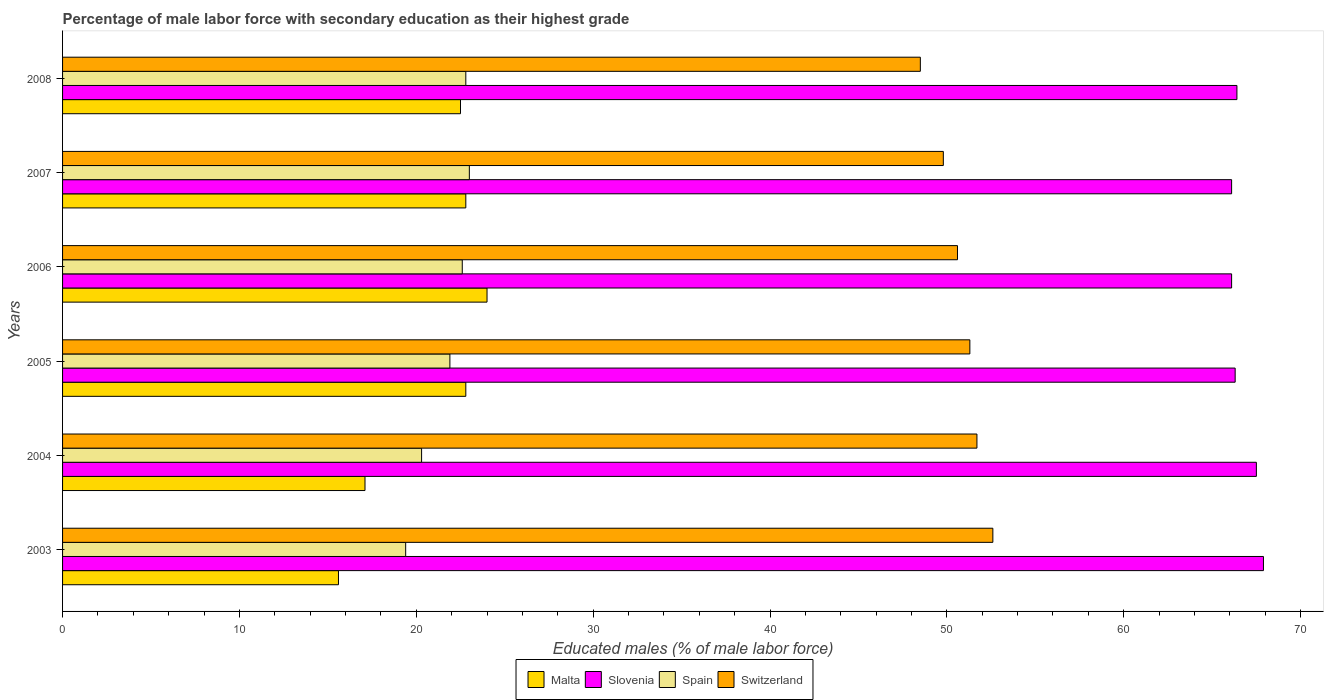How many different coloured bars are there?
Keep it short and to the point. 4. How many groups of bars are there?
Ensure brevity in your answer.  6. Are the number of bars per tick equal to the number of legend labels?
Offer a terse response. Yes. Are the number of bars on each tick of the Y-axis equal?
Your answer should be very brief. Yes. How many bars are there on the 6th tick from the bottom?
Provide a succinct answer. 4. What is the label of the 5th group of bars from the top?
Make the answer very short. 2004. In how many cases, is the number of bars for a given year not equal to the number of legend labels?
Provide a short and direct response. 0. What is the percentage of male labor force with secondary education in Slovenia in 2003?
Offer a terse response. 67.9. Across all years, what is the maximum percentage of male labor force with secondary education in Slovenia?
Provide a short and direct response. 67.9. Across all years, what is the minimum percentage of male labor force with secondary education in Spain?
Provide a succinct answer. 19.4. In which year was the percentage of male labor force with secondary education in Slovenia maximum?
Your answer should be very brief. 2003. In which year was the percentage of male labor force with secondary education in Slovenia minimum?
Offer a very short reply. 2006. What is the total percentage of male labor force with secondary education in Slovenia in the graph?
Give a very brief answer. 400.3. What is the difference between the percentage of male labor force with secondary education in Switzerland in 2004 and the percentage of male labor force with secondary education in Slovenia in 2008?
Provide a succinct answer. -14.7. What is the average percentage of male labor force with secondary education in Switzerland per year?
Offer a terse response. 50.75. In the year 2007, what is the difference between the percentage of male labor force with secondary education in Switzerland and percentage of male labor force with secondary education in Spain?
Provide a short and direct response. 26.8. What is the ratio of the percentage of male labor force with secondary education in Malta in 2003 to that in 2007?
Make the answer very short. 0.68. Is the percentage of male labor force with secondary education in Malta in 2006 less than that in 2008?
Your answer should be compact. No. What is the difference between the highest and the second highest percentage of male labor force with secondary education in Spain?
Give a very brief answer. 0.2. What is the difference between the highest and the lowest percentage of male labor force with secondary education in Malta?
Offer a terse response. 8.4. In how many years, is the percentage of male labor force with secondary education in Spain greater than the average percentage of male labor force with secondary education in Spain taken over all years?
Make the answer very short. 4. What does the 4th bar from the bottom in 2005 represents?
Offer a very short reply. Switzerland. Is it the case that in every year, the sum of the percentage of male labor force with secondary education in Switzerland and percentage of male labor force with secondary education in Spain is greater than the percentage of male labor force with secondary education in Malta?
Make the answer very short. Yes. Are the values on the major ticks of X-axis written in scientific E-notation?
Make the answer very short. No. Does the graph contain any zero values?
Make the answer very short. No. Does the graph contain grids?
Give a very brief answer. No. Where does the legend appear in the graph?
Provide a succinct answer. Bottom center. How many legend labels are there?
Ensure brevity in your answer.  4. What is the title of the graph?
Keep it short and to the point. Percentage of male labor force with secondary education as their highest grade. What is the label or title of the X-axis?
Keep it short and to the point. Educated males (% of male labor force). What is the Educated males (% of male labor force) in Malta in 2003?
Your answer should be compact. 15.6. What is the Educated males (% of male labor force) of Slovenia in 2003?
Your answer should be very brief. 67.9. What is the Educated males (% of male labor force) of Spain in 2003?
Provide a succinct answer. 19.4. What is the Educated males (% of male labor force) in Switzerland in 2003?
Ensure brevity in your answer.  52.6. What is the Educated males (% of male labor force) of Malta in 2004?
Ensure brevity in your answer.  17.1. What is the Educated males (% of male labor force) of Slovenia in 2004?
Your answer should be very brief. 67.5. What is the Educated males (% of male labor force) in Spain in 2004?
Offer a terse response. 20.3. What is the Educated males (% of male labor force) in Switzerland in 2004?
Your answer should be compact. 51.7. What is the Educated males (% of male labor force) of Malta in 2005?
Provide a succinct answer. 22.8. What is the Educated males (% of male labor force) of Slovenia in 2005?
Provide a short and direct response. 66.3. What is the Educated males (% of male labor force) of Spain in 2005?
Your answer should be very brief. 21.9. What is the Educated males (% of male labor force) of Switzerland in 2005?
Your answer should be compact. 51.3. What is the Educated males (% of male labor force) in Malta in 2006?
Your answer should be very brief. 24. What is the Educated males (% of male labor force) in Slovenia in 2006?
Make the answer very short. 66.1. What is the Educated males (% of male labor force) in Spain in 2006?
Ensure brevity in your answer.  22.6. What is the Educated males (% of male labor force) in Switzerland in 2006?
Provide a succinct answer. 50.6. What is the Educated males (% of male labor force) of Malta in 2007?
Make the answer very short. 22.8. What is the Educated males (% of male labor force) of Slovenia in 2007?
Offer a terse response. 66.1. What is the Educated males (% of male labor force) in Switzerland in 2007?
Provide a short and direct response. 49.8. What is the Educated males (% of male labor force) in Malta in 2008?
Provide a succinct answer. 22.5. What is the Educated males (% of male labor force) of Slovenia in 2008?
Your response must be concise. 66.4. What is the Educated males (% of male labor force) in Spain in 2008?
Your answer should be compact. 22.8. What is the Educated males (% of male labor force) of Switzerland in 2008?
Make the answer very short. 48.5. Across all years, what is the maximum Educated males (% of male labor force) of Malta?
Provide a succinct answer. 24. Across all years, what is the maximum Educated males (% of male labor force) of Slovenia?
Provide a short and direct response. 67.9. Across all years, what is the maximum Educated males (% of male labor force) in Spain?
Your response must be concise. 23. Across all years, what is the maximum Educated males (% of male labor force) of Switzerland?
Provide a succinct answer. 52.6. Across all years, what is the minimum Educated males (% of male labor force) in Malta?
Offer a very short reply. 15.6. Across all years, what is the minimum Educated males (% of male labor force) in Slovenia?
Provide a succinct answer. 66.1. Across all years, what is the minimum Educated males (% of male labor force) in Spain?
Offer a terse response. 19.4. Across all years, what is the minimum Educated males (% of male labor force) of Switzerland?
Provide a succinct answer. 48.5. What is the total Educated males (% of male labor force) of Malta in the graph?
Your response must be concise. 124.8. What is the total Educated males (% of male labor force) of Slovenia in the graph?
Provide a succinct answer. 400.3. What is the total Educated males (% of male labor force) in Spain in the graph?
Your answer should be very brief. 130. What is the total Educated males (% of male labor force) in Switzerland in the graph?
Make the answer very short. 304.5. What is the difference between the Educated males (% of male labor force) of Malta in 2003 and that in 2004?
Give a very brief answer. -1.5. What is the difference between the Educated males (% of male labor force) in Spain in 2003 and that in 2004?
Keep it short and to the point. -0.9. What is the difference between the Educated males (% of male labor force) of Malta in 2003 and that in 2005?
Your answer should be very brief. -7.2. What is the difference between the Educated males (% of male labor force) of Slovenia in 2003 and that in 2005?
Ensure brevity in your answer.  1.6. What is the difference between the Educated males (% of male labor force) of Switzerland in 2003 and that in 2005?
Offer a terse response. 1.3. What is the difference between the Educated males (% of male labor force) of Malta in 2003 and that in 2006?
Give a very brief answer. -8.4. What is the difference between the Educated males (% of male labor force) in Malta in 2003 and that in 2007?
Offer a very short reply. -7.2. What is the difference between the Educated males (% of male labor force) in Slovenia in 2003 and that in 2007?
Offer a terse response. 1.8. What is the difference between the Educated males (% of male labor force) of Spain in 2003 and that in 2007?
Keep it short and to the point. -3.6. What is the difference between the Educated males (% of male labor force) in Switzerland in 2003 and that in 2007?
Provide a succinct answer. 2.8. What is the difference between the Educated males (% of male labor force) of Malta in 2003 and that in 2008?
Keep it short and to the point. -6.9. What is the difference between the Educated males (% of male labor force) of Slovenia in 2003 and that in 2008?
Your response must be concise. 1.5. What is the difference between the Educated males (% of male labor force) in Malta in 2004 and that in 2005?
Your response must be concise. -5.7. What is the difference between the Educated males (% of male labor force) in Spain in 2004 and that in 2005?
Make the answer very short. -1.6. What is the difference between the Educated males (% of male labor force) of Malta in 2004 and that in 2006?
Your response must be concise. -6.9. What is the difference between the Educated males (% of male labor force) of Slovenia in 2004 and that in 2006?
Provide a succinct answer. 1.4. What is the difference between the Educated males (% of male labor force) in Spain in 2004 and that in 2006?
Ensure brevity in your answer.  -2.3. What is the difference between the Educated males (% of male labor force) of Spain in 2004 and that in 2007?
Offer a terse response. -2.7. What is the difference between the Educated males (% of male labor force) of Switzerland in 2004 and that in 2007?
Offer a terse response. 1.9. What is the difference between the Educated males (% of male labor force) in Slovenia in 2004 and that in 2008?
Keep it short and to the point. 1.1. What is the difference between the Educated males (% of male labor force) of Switzerland in 2004 and that in 2008?
Make the answer very short. 3.2. What is the difference between the Educated males (% of male labor force) of Malta in 2005 and that in 2006?
Keep it short and to the point. -1.2. What is the difference between the Educated males (% of male labor force) of Slovenia in 2005 and that in 2006?
Your answer should be compact. 0.2. What is the difference between the Educated males (% of male labor force) of Switzerland in 2005 and that in 2006?
Offer a very short reply. 0.7. What is the difference between the Educated males (% of male labor force) of Slovenia in 2005 and that in 2007?
Provide a succinct answer. 0.2. What is the difference between the Educated males (% of male labor force) in Spain in 2005 and that in 2007?
Provide a short and direct response. -1.1. What is the difference between the Educated males (% of male labor force) of Slovenia in 2005 and that in 2008?
Give a very brief answer. -0.1. What is the difference between the Educated males (% of male labor force) in Switzerland in 2005 and that in 2008?
Make the answer very short. 2.8. What is the difference between the Educated males (% of male labor force) of Slovenia in 2006 and that in 2007?
Offer a terse response. 0. What is the difference between the Educated males (% of male labor force) in Spain in 2006 and that in 2007?
Give a very brief answer. -0.4. What is the difference between the Educated males (% of male labor force) of Switzerland in 2006 and that in 2007?
Offer a very short reply. 0.8. What is the difference between the Educated males (% of male labor force) in Malta in 2006 and that in 2008?
Provide a succinct answer. 1.5. What is the difference between the Educated males (% of male labor force) of Spain in 2006 and that in 2008?
Give a very brief answer. -0.2. What is the difference between the Educated males (% of male labor force) in Malta in 2007 and that in 2008?
Offer a very short reply. 0.3. What is the difference between the Educated males (% of male labor force) in Spain in 2007 and that in 2008?
Your answer should be very brief. 0.2. What is the difference between the Educated males (% of male labor force) of Switzerland in 2007 and that in 2008?
Your answer should be very brief. 1.3. What is the difference between the Educated males (% of male labor force) in Malta in 2003 and the Educated males (% of male labor force) in Slovenia in 2004?
Make the answer very short. -51.9. What is the difference between the Educated males (% of male labor force) of Malta in 2003 and the Educated males (% of male labor force) of Spain in 2004?
Keep it short and to the point. -4.7. What is the difference between the Educated males (% of male labor force) of Malta in 2003 and the Educated males (% of male labor force) of Switzerland in 2004?
Your response must be concise. -36.1. What is the difference between the Educated males (% of male labor force) of Slovenia in 2003 and the Educated males (% of male labor force) of Spain in 2004?
Ensure brevity in your answer.  47.6. What is the difference between the Educated males (% of male labor force) in Spain in 2003 and the Educated males (% of male labor force) in Switzerland in 2004?
Provide a succinct answer. -32.3. What is the difference between the Educated males (% of male labor force) in Malta in 2003 and the Educated males (% of male labor force) in Slovenia in 2005?
Provide a succinct answer. -50.7. What is the difference between the Educated males (% of male labor force) in Malta in 2003 and the Educated males (% of male labor force) in Switzerland in 2005?
Give a very brief answer. -35.7. What is the difference between the Educated males (% of male labor force) of Slovenia in 2003 and the Educated males (% of male labor force) of Spain in 2005?
Your response must be concise. 46. What is the difference between the Educated males (% of male labor force) of Spain in 2003 and the Educated males (% of male labor force) of Switzerland in 2005?
Ensure brevity in your answer.  -31.9. What is the difference between the Educated males (% of male labor force) of Malta in 2003 and the Educated males (% of male labor force) of Slovenia in 2006?
Give a very brief answer. -50.5. What is the difference between the Educated males (% of male labor force) in Malta in 2003 and the Educated males (% of male labor force) in Switzerland in 2006?
Offer a terse response. -35. What is the difference between the Educated males (% of male labor force) in Slovenia in 2003 and the Educated males (% of male labor force) in Spain in 2006?
Offer a very short reply. 45.3. What is the difference between the Educated males (% of male labor force) of Spain in 2003 and the Educated males (% of male labor force) of Switzerland in 2006?
Keep it short and to the point. -31.2. What is the difference between the Educated males (% of male labor force) in Malta in 2003 and the Educated males (% of male labor force) in Slovenia in 2007?
Make the answer very short. -50.5. What is the difference between the Educated males (% of male labor force) in Malta in 2003 and the Educated males (% of male labor force) in Spain in 2007?
Ensure brevity in your answer.  -7.4. What is the difference between the Educated males (% of male labor force) of Malta in 2003 and the Educated males (% of male labor force) of Switzerland in 2007?
Make the answer very short. -34.2. What is the difference between the Educated males (% of male labor force) in Slovenia in 2003 and the Educated males (% of male labor force) in Spain in 2007?
Keep it short and to the point. 44.9. What is the difference between the Educated males (% of male labor force) of Slovenia in 2003 and the Educated males (% of male labor force) of Switzerland in 2007?
Make the answer very short. 18.1. What is the difference between the Educated males (% of male labor force) in Spain in 2003 and the Educated males (% of male labor force) in Switzerland in 2007?
Your answer should be compact. -30.4. What is the difference between the Educated males (% of male labor force) in Malta in 2003 and the Educated males (% of male labor force) in Slovenia in 2008?
Keep it short and to the point. -50.8. What is the difference between the Educated males (% of male labor force) in Malta in 2003 and the Educated males (% of male labor force) in Switzerland in 2008?
Your answer should be very brief. -32.9. What is the difference between the Educated males (% of male labor force) of Slovenia in 2003 and the Educated males (% of male labor force) of Spain in 2008?
Your response must be concise. 45.1. What is the difference between the Educated males (% of male labor force) of Spain in 2003 and the Educated males (% of male labor force) of Switzerland in 2008?
Offer a terse response. -29.1. What is the difference between the Educated males (% of male labor force) in Malta in 2004 and the Educated males (% of male labor force) in Slovenia in 2005?
Offer a very short reply. -49.2. What is the difference between the Educated males (% of male labor force) in Malta in 2004 and the Educated males (% of male labor force) in Spain in 2005?
Give a very brief answer. -4.8. What is the difference between the Educated males (% of male labor force) in Malta in 2004 and the Educated males (% of male labor force) in Switzerland in 2005?
Give a very brief answer. -34.2. What is the difference between the Educated males (% of male labor force) in Slovenia in 2004 and the Educated males (% of male labor force) in Spain in 2005?
Make the answer very short. 45.6. What is the difference between the Educated males (% of male labor force) of Slovenia in 2004 and the Educated males (% of male labor force) of Switzerland in 2005?
Make the answer very short. 16.2. What is the difference between the Educated males (% of male labor force) of Spain in 2004 and the Educated males (% of male labor force) of Switzerland in 2005?
Keep it short and to the point. -31. What is the difference between the Educated males (% of male labor force) in Malta in 2004 and the Educated males (% of male labor force) in Slovenia in 2006?
Make the answer very short. -49. What is the difference between the Educated males (% of male labor force) in Malta in 2004 and the Educated males (% of male labor force) in Switzerland in 2006?
Keep it short and to the point. -33.5. What is the difference between the Educated males (% of male labor force) of Slovenia in 2004 and the Educated males (% of male labor force) of Spain in 2006?
Make the answer very short. 44.9. What is the difference between the Educated males (% of male labor force) of Spain in 2004 and the Educated males (% of male labor force) of Switzerland in 2006?
Make the answer very short. -30.3. What is the difference between the Educated males (% of male labor force) in Malta in 2004 and the Educated males (% of male labor force) in Slovenia in 2007?
Offer a very short reply. -49. What is the difference between the Educated males (% of male labor force) in Malta in 2004 and the Educated males (% of male labor force) in Switzerland in 2007?
Offer a terse response. -32.7. What is the difference between the Educated males (% of male labor force) in Slovenia in 2004 and the Educated males (% of male labor force) in Spain in 2007?
Keep it short and to the point. 44.5. What is the difference between the Educated males (% of male labor force) of Slovenia in 2004 and the Educated males (% of male labor force) of Switzerland in 2007?
Offer a very short reply. 17.7. What is the difference between the Educated males (% of male labor force) of Spain in 2004 and the Educated males (% of male labor force) of Switzerland in 2007?
Your response must be concise. -29.5. What is the difference between the Educated males (% of male labor force) in Malta in 2004 and the Educated males (% of male labor force) in Slovenia in 2008?
Offer a terse response. -49.3. What is the difference between the Educated males (% of male labor force) in Malta in 2004 and the Educated males (% of male labor force) in Switzerland in 2008?
Keep it short and to the point. -31.4. What is the difference between the Educated males (% of male labor force) in Slovenia in 2004 and the Educated males (% of male labor force) in Spain in 2008?
Offer a very short reply. 44.7. What is the difference between the Educated males (% of male labor force) in Spain in 2004 and the Educated males (% of male labor force) in Switzerland in 2008?
Keep it short and to the point. -28.2. What is the difference between the Educated males (% of male labor force) in Malta in 2005 and the Educated males (% of male labor force) in Slovenia in 2006?
Provide a succinct answer. -43.3. What is the difference between the Educated males (% of male labor force) in Malta in 2005 and the Educated males (% of male labor force) in Spain in 2006?
Your answer should be very brief. 0.2. What is the difference between the Educated males (% of male labor force) of Malta in 2005 and the Educated males (% of male labor force) of Switzerland in 2006?
Your answer should be compact. -27.8. What is the difference between the Educated males (% of male labor force) in Slovenia in 2005 and the Educated males (% of male labor force) in Spain in 2006?
Your response must be concise. 43.7. What is the difference between the Educated males (% of male labor force) in Spain in 2005 and the Educated males (% of male labor force) in Switzerland in 2006?
Your answer should be very brief. -28.7. What is the difference between the Educated males (% of male labor force) of Malta in 2005 and the Educated males (% of male labor force) of Slovenia in 2007?
Offer a very short reply. -43.3. What is the difference between the Educated males (% of male labor force) of Malta in 2005 and the Educated males (% of male labor force) of Switzerland in 2007?
Keep it short and to the point. -27. What is the difference between the Educated males (% of male labor force) of Slovenia in 2005 and the Educated males (% of male labor force) of Spain in 2007?
Offer a very short reply. 43.3. What is the difference between the Educated males (% of male labor force) of Slovenia in 2005 and the Educated males (% of male labor force) of Switzerland in 2007?
Give a very brief answer. 16.5. What is the difference between the Educated males (% of male labor force) in Spain in 2005 and the Educated males (% of male labor force) in Switzerland in 2007?
Keep it short and to the point. -27.9. What is the difference between the Educated males (% of male labor force) of Malta in 2005 and the Educated males (% of male labor force) of Slovenia in 2008?
Your response must be concise. -43.6. What is the difference between the Educated males (% of male labor force) in Malta in 2005 and the Educated males (% of male labor force) in Spain in 2008?
Your answer should be compact. 0. What is the difference between the Educated males (% of male labor force) of Malta in 2005 and the Educated males (% of male labor force) of Switzerland in 2008?
Keep it short and to the point. -25.7. What is the difference between the Educated males (% of male labor force) in Slovenia in 2005 and the Educated males (% of male labor force) in Spain in 2008?
Offer a very short reply. 43.5. What is the difference between the Educated males (% of male labor force) in Spain in 2005 and the Educated males (% of male labor force) in Switzerland in 2008?
Provide a short and direct response. -26.6. What is the difference between the Educated males (% of male labor force) in Malta in 2006 and the Educated males (% of male labor force) in Slovenia in 2007?
Provide a succinct answer. -42.1. What is the difference between the Educated males (% of male labor force) of Malta in 2006 and the Educated males (% of male labor force) of Switzerland in 2007?
Keep it short and to the point. -25.8. What is the difference between the Educated males (% of male labor force) of Slovenia in 2006 and the Educated males (% of male labor force) of Spain in 2007?
Your answer should be compact. 43.1. What is the difference between the Educated males (% of male labor force) of Spain in 2006 and the Educated males (% of male labor force) of Switzerland in 2007?
Give a very brief answer. -27.2. What is the difference between the Educated males (% of male labor force) in Malta in 2006 and the Educated males (% of male labor force) in Slovenia in 2008?
Your answer should be very brief. -42.4. What is the difference between the Educated males (% of male labor force) in Malta in 2006 and the Educated males (% of male labor force) in Spain in 2008?
Your answer should be very brief. 1.2. What is the difference between the Educated males (% of male labor force) of Malta in 2006 and the Educated males (% of male labor force) of Switzerland in 2008?
Make the answer very short. -24.5. What is the difference between the Educated males (% of male labor force) in Slovenia in 2006 and the Educated males (% of male labor force) in Spain in 2008?
Ensure brevity in your answer.  43.3. What is the difference between the Educated males (% of male labor force) of Slovenia in 2006 and the Educated males (% of male labor force) of Switzerland in 2008?
Provide a short and direct response. 17.6. What is the difference between the Educated males (% of male labor force) of Spain in 2006 and the Educated males (% of male labor force) of Switzerland in 2008?
Make the answer very short. -25.9. What is the difference between the Educated males (% of male labor force) in Malta in 2007 and the Educated males (% of male labor force) in Slovenia in 2008?
Offer a very short reply. -43.6. What is the difference between the Educated males (% of male labor force) in Malta in 2007 and the Educated males (% of male labor force) in Spain in 2008?
Offer a very short reply. 0. What is the difference between the Educated males (% of male labor force) of Malta in 2007 and the Educated males (% of male labor force) of Switzerland in 2008?
Provide a short and direct response. -25.7. What is the difference between the Educated males (% of male labor force) in Slovenia in 2007 and the Educated males (% of male labor force) in Spain in 2008?
Keep it short and to the point. 43.3. What is the difference between the Educated males (% of male labor force) of Slovenia in 2007 and the Educated males (% of male labor force) of Switzerland in 2008?
Give a very brief answer. 17.6. What is the difference between the Educated males (% of male labor force) of Spain in 2007 and the Educated males (% of male labor force) of Switzerland in 2008?
Provide a short and direct response. -25.5. What is the average Educated males (% of male labor force) in Malta per year?
Ensure brevity in your answer.  20.8. What is the average Educated males (% of male labor force) in Slovenia per year?
Provide a succinct answer. 66.72. What is the average Educated males (% of male labor force) of Spain per year?
Provide a succinct answer. 21.67. What is the average Educated males (% of male labor force) in Switzerland per year?
Your answer should be very brief. 50.75. In the year 2003, what is the difference between the Educated males (% of male labor force) of Malta and Educated males (% of male labor force) of Slovenia?
Provide a short and direct response. -52.3. In the year 2003, what is the difference between the Educated males (% of male labor force) of Malta and Educated males (% of male labor force) of Switzerland?
Your answer should be very brief. -37. In the year 2003, what is the difference between the Educated males (% of male labor force) of Slovenia and Educated males (% of male labor force) of Spain?
Offer a very short reply. 48.5. In the year 2003, what is the difference between the Educated males (% of male labor force) of Spain and Educated males (% of male labor force) of Switzerland?
Your answer should be compact. -33.2. In the year 2004, what is the difference between the Educated males (% of male labor force) in Malta and Educated males (% of male labor force) in Slovenia?
Your response must be concise. -50.4. In the year 2004, what is the difference between the Educated males (% of male labor force) in Malta and Educated males (% of male labor force) in Spain?
Ensure brevity in your answer.  -3.2. In the year 2004, what is the difference between the Educated males (% of male labor force) of Malta and Educated males (% of male labor force) of Switzerland?
Ensure brevity in your answer.  -34.6. In the year 2004, what is the difference between the Educated males (% of male labor force) in Slovenia and Educated males (% of male labor force) in Spain?
Your answer should be compact. 47.2. In the year 2004, what is the difference between the Educated males (% of male labor force) of Slovenia and Educated males (% of male labor force) of Switzerland?
Your response must be concise. 15.8. In the year 2004, what is the difference between the Educated males (% of male labor force) of Spain and Educated males (% of male labor force) of Switzerland?
Offer a terse response. -31.4. In the year 2005, what is the difference between the Educated males (% of male labor force) in Malta and Educated males (% of male labor force) in Slovenia?
Ensure brevity in your answer.  -43.5. In the year 2005, what is the difference between the Educated males (% of male labor force) of Malta and Educated males (% of male labor force) of Switzerland?
Your response must be concise. -28.5. In the year 2005, what is the difference between the Educated males (% of male labor force) of Slovenia and Educated males (% of male labor force) of Spain?
Keep it short and to the point. 44.4. In the year 2005, what is the difference between the Educated males (% of male labor force) in Spain and Educated males (% of male labor force) in Switzerland?
Provide a succinct answer. -29.4. In the year 2006, what is the difference between the Educated males (% of male labor force) in Malta and Educated males (% of male labor force) in Slovenia?
Offer a terse response. -42.1. In the year 2006, what is the difference between the Educated males (% of male labor force) in Malta and Educated males (% of male labor force) in Spain?
Give a very brief answer. 1.4. In the year 2006, what is the difference between the Educated males (% of male labor force) in Malta and Educated males (% of male labor force) in Switzerland?
Give a very brief answer. -26.6. In the year 2006, what is the difference between the Educated males (% of male labor force) of Slovenia and Educated males (% of male labor force) of Spain?
Ensure brevity in your answer.  43.5. In the year 2006, what is the difference between the Educated males (% of male labor force) in Spain and Educated males (% of male labor force) in Switzerland?
Give a very brief answer. -28. In the year 2007, what is the difference between the Educated males (% of male labor force) in Malta and Educated males (% of male labor force) in Slovenia?
Give a very brief answer. -43.3. In the year 2007, what is the difference between the Educated males (% of male labor force) in Malta and Educated males (% of male labor force) in Spain?
Offer a terse response. -0.2. In the year 2007, what is the difference between the Educated males (% of male labor force) in Slovenia and Educated males (% of male labor force) in Spain?
Your answer should be compact. 43.1. In the year 2007, what is the difference between the Educated males (% of male labor force) of Spain and Educated males (% of male labor force) of Switzerland?
Provide a short and direct response. -26.8. In the year 2008, what is the difference between the Educated males (% of male labor force) in Malta and Educated males (% of male labor force) in Slovenia?
Give a very brief answer. -43.9. In the year 2008, what is the difference between the Educated males (% of male labor force) of Malta and Educated males (% of male labor force) of Spain?
Your answer should be compact. -0.3. In the year 2008, what is the difference between the Educated males (% of male labor force) in Malta and Educated males (% of male labor force) in Switzerland?
Keep it short and to the point. -26. In the year 2008, what is the difference between the Educated males (% of male labor force) of Slovenia and Educated males (% of male labor force) of Spain?
Make the answer very short. 43.6. In the year 2008, what is the difference between the Educated males (% of male labor force) of Slovenia and Educated males (% of male labor force) of Switzerland?
Give a very brief answer. 17.9. In the year 2008, what is the difference between the Educated males (% of male labor force) in Spain and Educated males (% of male labor force) in Switzerland?
Provide a short and direct response. -25.7. What is the ratio of the Educated males (% of male labor force) of Malta in 2003 to that in 2004?
Provide a succinct answer. 0.91. What is the ratio of the Educated males (% of male labor force) of Slovenia in 2003 to that in 2004?
Offer a very short reply. 1.01. What is the ratio of the Educated males (% of male labor force) in Spain in 2003 to that in 2004?
Keep it short and to the point. 0.96. What is the ratio of the Educated males (% of male labor force) in Switzerland in 2003 to that in 2004?
Provide a short and direct response. 1.02. What is the ratio of the Educated males (% of male labor force) of Malta in 2003 to that in 2005?
Provide a succinct answer. 0.68. What is the ratio of the Educated males (% of male labor force) of Slovenia in 2003 to that in 2005?
Offer a very short reply. 1.02. What is the ratio of the Educated males (% of male labor force) of Spain in 2003 to that in 2005?
Your answer should be compact. 0.89. What is the ratio of the Educated males (% of male labor force) in Switzerland in 2003 to that in 2005?
Provide a succinct answer. 1.03. What is the ratio of the Educated males (% of male labor force) in Malta in 2003 to that in 2006?
Your answer should be very brief. 0.65. What is the ratio of the Educated males (% of male labor force) in Slovenia in 2003 to that in 2006?
Give a very brief answer. 1.03. What is the ratio of the Educated males (% of male labor force) of Spain in 2003 to that in 2006?
Your answer should be compact. 0.86. What is the ratio of the Educated males (% of male labor force) of Switzerland in 2003 to that in 2006?
Your answer should be very brief. 1.04. What is the ratio of the Educated males (% of male labor force) in Malta in 2003 to that in 2007?
Your response must be concise. 0.68. What is the ratio of the Educated males (% of male labor force) in Slovenia in 2003 to that in 2007?
Your answer should be very brief. 1.03. What is the ratio of the Educated males (% of male labor force) in Spain in 2003 to that in 2007?
Your response must be concise. 0.84. What is the ratio of the Educated males (% of male labor force) of Switzerland in 2003 to that in 2007?
Provide a short and direct response. 1.06. What is the ratio of the Educated males (% of male labor force) of Malta in 2003 to that in 2008?
Your answer should be compact. 0.69. What is the ratio of the Educated males (% of male labor force) in Slovenia in 2003 to that in 2008?
Your answer should be compact. 1.02. What is the ratio of the Educated males (% of male labor force) in Spain in 2003 to that in 2008?
Keep it short and to the point. 0.85. What is the ratio of the Educated males (% of male labor force) of Switzerland in 2003 to that in 2008?
Offer a very short reply. 1.08. What is the ratio of the Educated males (% of male labor force) of Malta in 2004 to that in 2005?
Offer a very short reply. 0.75. What is the ratio of the Educated males (% of male labor force) of Slovenia in 2004 to that in 2005?
Your response must be concise. 1.02. What is the ratio of the Educated males (% of male labor force) in Spain in 2004 to that in 2005?
Offer a very short reply. 0.93. What is the ratio of the Educated males (% of male labor force) in Switzerland in 2004 to that in 2005?
Provide a short and direct response. 1.01. What is the ratio of the Educated males (% of male labor force) of Malta in 2004 to that in 2006?
Your answer should be compact. 0.71. What is the ratio of the Educated males (% of male labor force) of Slovenia in 2004 to that in 2006?
Your answer should be compact. 1.02. What is the ratio of the Educated males (% of male labor force) of Spain in 2004 to that in 2006?
Your answer should be very brief. 0.9. What is the ratio of the Educated males (% of male labor force) in Switzerland in 2004 to that in 2006?
Keep it short and to the point. 1.02. What is the ratio of the Educated males (% of male labor force) in Slovenia in 2004 to that in 2007?
Make the answer very short. 1.02. What is the ratio of the Educated males (% of male labor force) of Spain in 2004 to that in 2007?
Give a very brief answer. 0.88. What is the ratio of the Educated males (% of male labor force) in Switzerland in 2004 to that in 2007?
Ensure brevity in your answer.  1.04. What is the ratio of the Educated males (% of male labor force) of Malta in 2004 to that in 2008?
Provide a short and direct response. 0.76. What is the ratio of the Educated males (% of male labor force) of Slovenia in 2004 to that in 2008?
Provide a succinct answer. 1.02. What is the ratio of the Educated males (% of male labor force) of Spain in 2004 to that in 2008?
Make the answer very short. 0.89. What is the ratio of the Educated males (% of male labor force) in Switzerland in 2004 to that in 2008?
Give a very brief answer. 1.07. What is the ratio of the Educated males (% of male labor force) in Spain in 2005 to that in 2006?
Offer a very short reply. 0.97. What is the ratio of the Educated males (% of male labor force) of Switzerland in 2005 to that in 2006?
Keep it short and to the point. 1.01. What is the ratio of the Educated males (% of male labor force) of Spain in 2005 to that in 2007?
Ensure brevity in your answer.  0.95. What is the ratio of the Educated males (% of male labor force) in Switzerland in 2005 to that in 2007?
Ensure brevity in your answer.  1.03. What is the ratio of the Educated males (% of male labor force) of Malta in 2005 to that in 2008?
Offer a terse response. 1.01. What is the ratio of the Educated males (% of male labor force) in Spain in 2005 to that in 2008?
Make the answer very short. 0.96. What is the ratio of the Educated males (% of male labor force) in Switzerland in 2005 to that in 2008?
Provide a succinct answer. 1.06. What is the ratio of the Educated males (% of male labor force) of Malta in 2006 to that in 2007?
Your response must be concise. 1.05. What is the ratio of the Educated males (% of male labor force) of Slovenia in 2006 to that in 2007?
Provide a short and direct response. 1. What is the ratio of the Educated males (% of male labor force) of Spain in 2006 to that in 2007?
Offer a terse response. 0.98. What is the ratio of the Educated males (% of male labor force) in Switzerland in 2006 to that in 2007?
Make the answer very short. 1.02. What is the ratio of the Educated males (% of male labor force) in Malta in 2006 to that in 2008?
Make the answer very short. 1.07. What is the ratio of the Educated males (% of male labor force) of Slovenia in 2006 to that in 2008?
Give a very brief answer. 1. What is the ratio of the Educated males (% of male labor force) of Spain in 2006 to that in 2008?
Offer a terse response. 0.99. What is the ratio of the Educated males (% of male labor force) of Switzerland in 2006 to that in 2008?
Ensure brevity in your answer.  1.04. What is the ratio of the Educated males (% of male labor force) in Malta in 2007 to that in 2008?
Your answer should be compact. 1.01. What is the ratio of the Educated males (% of male labor force) of Spain in 2007 to that in 2008?
Make the answer very short. 1.01. What is the ratio of the Educated males (% of male labor force) in Switzerland in 2007 to that in 2008?
Offer a very short reply. 1.03. What is the difference between the highest and the second highest Educated males (% of male labor force) in Slovenia?
Offer a terse response. 0.4. What is the difference between the highest and the second highest Educated males (% of male labor force) of Spain?
Ensure brevity in your answer.  0.2. What is the difference between the highest and the lowest Educated males (% of male labor force) of Spain?
Provide a succinct answer. 3.6. What is the difference between the highest and the lowest Educated males (% of male labor force) in Switzerland?
Provide a short and direct response. 4.1. 